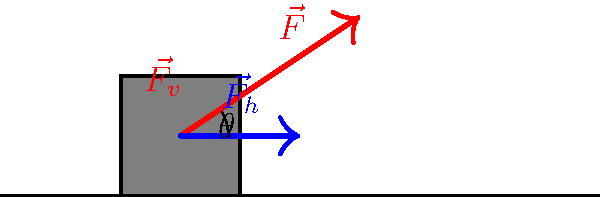As a former sprinter, you understand the importance of a powerful start. In the diagram, a force $\vec{F}$ is applied to the starting block at an angle $\theta$ to the horizontal. If the magnitude of $\vec{F}$ is 800 N and $\theta = 30°$, calculate the horizontal component of the force ($\vec{F_h}$) that propels the sprinter forward. To solve this problem, we'll follow these steps:

1. Recall the trigonometric relationship for resolving forces:
   The horizontal component of a force is given by $F_h = F \cos(\theta)$

2. We're given:
   - The magnitude of the total force, $F = 800$ N
   - The angle to the horizontal, $\theta = 30°$

3. Substitute these values into the equation:
   $F_h = 800 \cos(30°)$

4. Recall that $\cos(30°) = \frac{\sqrt{3}}{2}$

5. Calculate:
   $F_h = 800 \cdot \frac{\sqrt{3}}{2} = 400\sqrt{3}$ N

6. If needed, we can approximate this:
   $400\sqrt{3} \approx 692.82$ N

Therefore, the horizontal component of the force propelling the sprinter forward is $400\sqrt{3}$ N or approximately 692.82 N.
Answer: $400\sqrt{3}$ N 